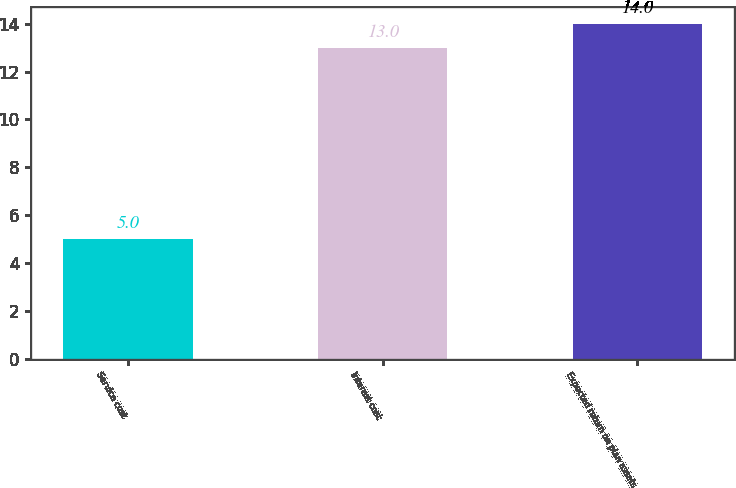Convert chart. <chart><loc_0><loc_0><loc_500><loc_500><bar_chart><fcel>Service cost<fcel>Interest cost<fcel>Expected return on plan assets<nl><fcel>5<fcel>13<fcel>14<nl></chart> 